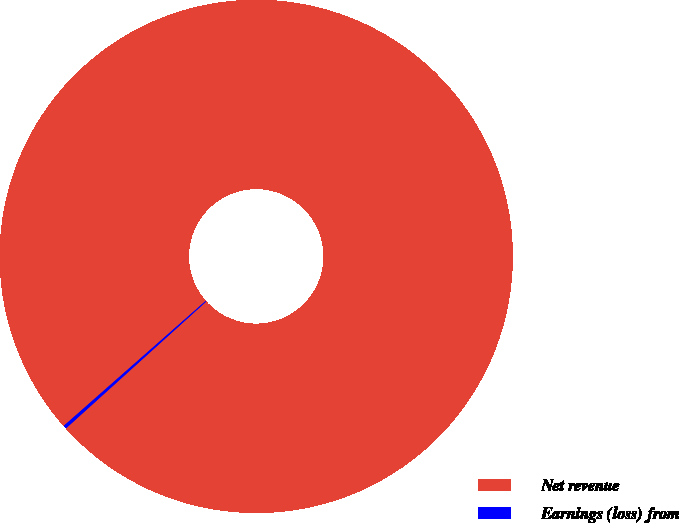Convert chart. <chart><loc_0><loc_0><loc_500><loc_500><pie_chart><fcel>Net revenue<fcel>Earnings (loss) from<nl><fcel>99.79%<fcel>0.21%<nl></chart> 